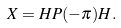<formula> <loc_0><loc_0><loc_500><loc_500>X = H P ( - \pi ) H .</formula> 